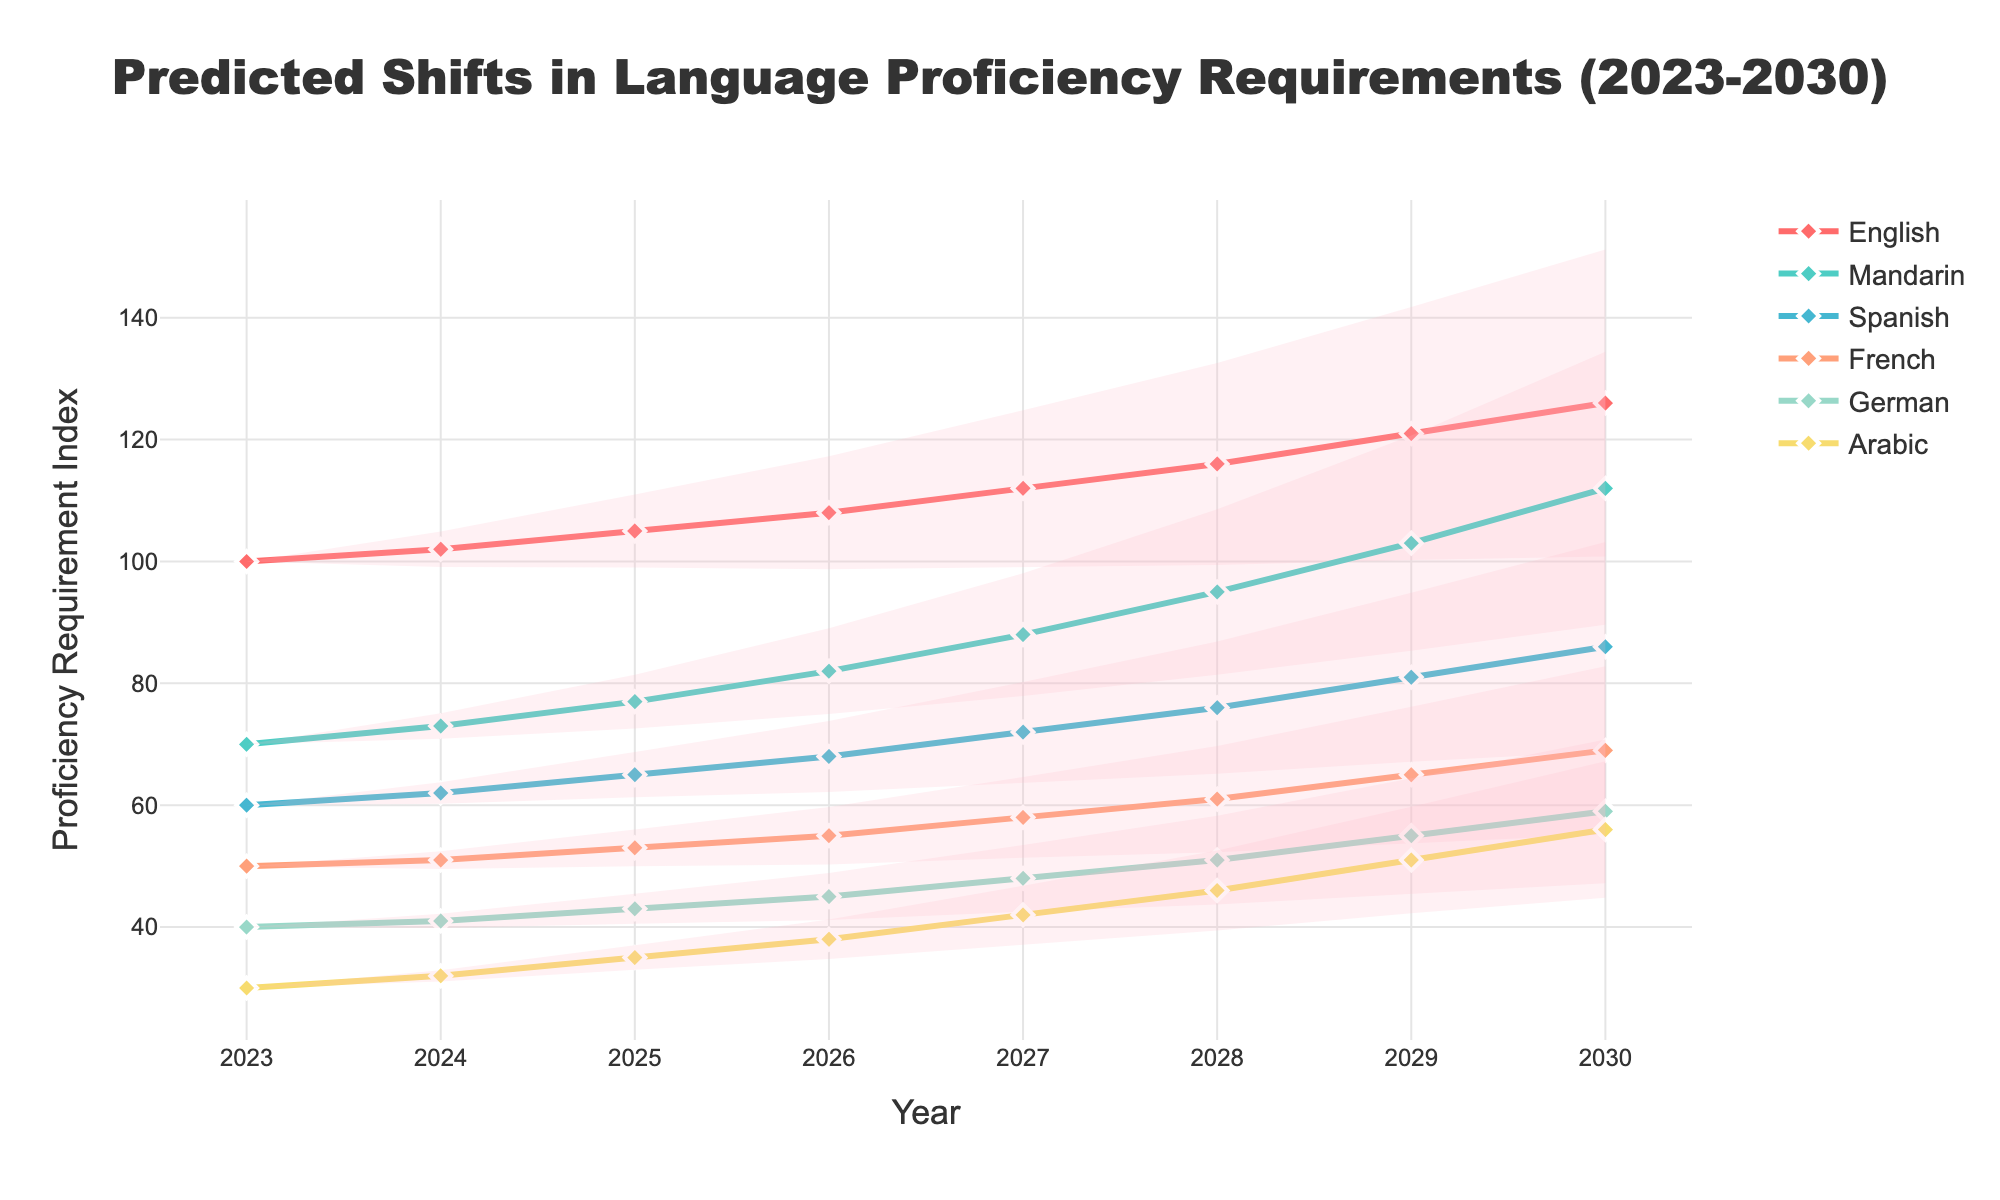What is the title of the chart? The title is prominently displayed at the top center of the chart. It reads 'Predicted Shifts in Language Proficiency Requirements (2023-2030)'.
Answer: Predicted Shifts in Language Proficiency Requirements (2023-2030) Which years are covered in the chart? The x-axis labels represent the years from 2023 to 2030. You can see this by following the x-axis from start to end.
Answer: 2023-2030 Which language has the highest proficiency requirement in 2030? The y-axis values show the proficiency requirement index. In 2030, English has the highest index value.
Answer: English What's the difference in proficiency requirement between Mandarin and Spanish in 2027? From the 2027 points on the chart, Mandarin has an index of 88 and Spanish has an index of 72. Subtracting the two values gives the difference.
Answer: 16 How does the proficiency requirement for Arabic change from 2023 to 2030? Trace the values for Arabic from 2023 (30) to 2030 (56). The difference is 56 - 30.
Answer: 26 Which language shows the steepest increase in proficiency requirement from 2023 to 2030? By comparing the slopes of the lines, English has the steepest increase, going from 100 in 2023 to 126 in 2030.
Answer: English What is the predicted proficiency requirement index for French in 2028? Locate the year 2028 on the x-axis and follow it vertically to the line for French. The proficiency index for French is 61.
Answer: 61 Compare the proficiency requirement for German and French in 2025. Which is higher and by how much? In 2025, German has a proficiency index of 43, and French has a proficiency index of 53. French is higher by 10 points.
Answer: French, 10 What is the average proficiency requirement index of Spanish from 2023 to 2030? Add the indices of Spanish for each year and divide by the number of years (8). (60+62+65+68+72+76+81+86)/8.
Answer: 71 How does the fan chart illustrate uncertainty in predictions? The fan chart uses shaded areas to show upper and lower bounds around each language's line, representing possible variations in future projections.
Answer: Shaded areas showing upper and lower bounds 